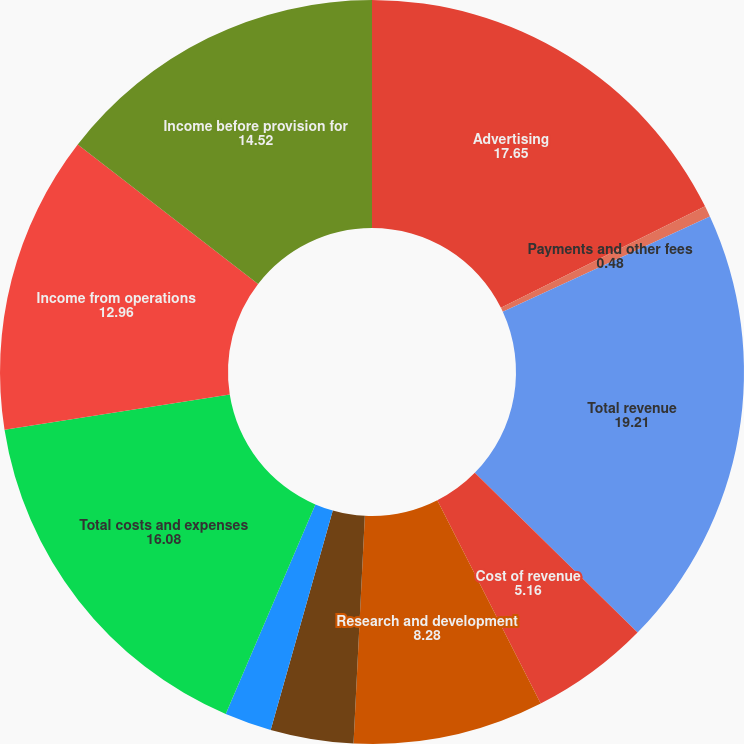Convert chart to OTSL. <chart><loc_0><loc_0><loc_500><loc_500><pie_chart><fcel>Advertising<fcel>Payments and other fees<fcel>Total revenue<fcel>Cost of revenue<fcel>Research and development<fcel>Marketing and sales<fcel>General and administrative<fcel>Total costs and expenses<fcel>Income from operations<fcel>Income before provision for<nl><fcel>17.65%<fcel>0.48%<fcel>19.21%<fcel>5.16%<fcel>8.28%<fcel>3.6%<fcel>2.04%<fcel>16.08%<fcel>12.96%<fcel>14.52%<nl></chart> 